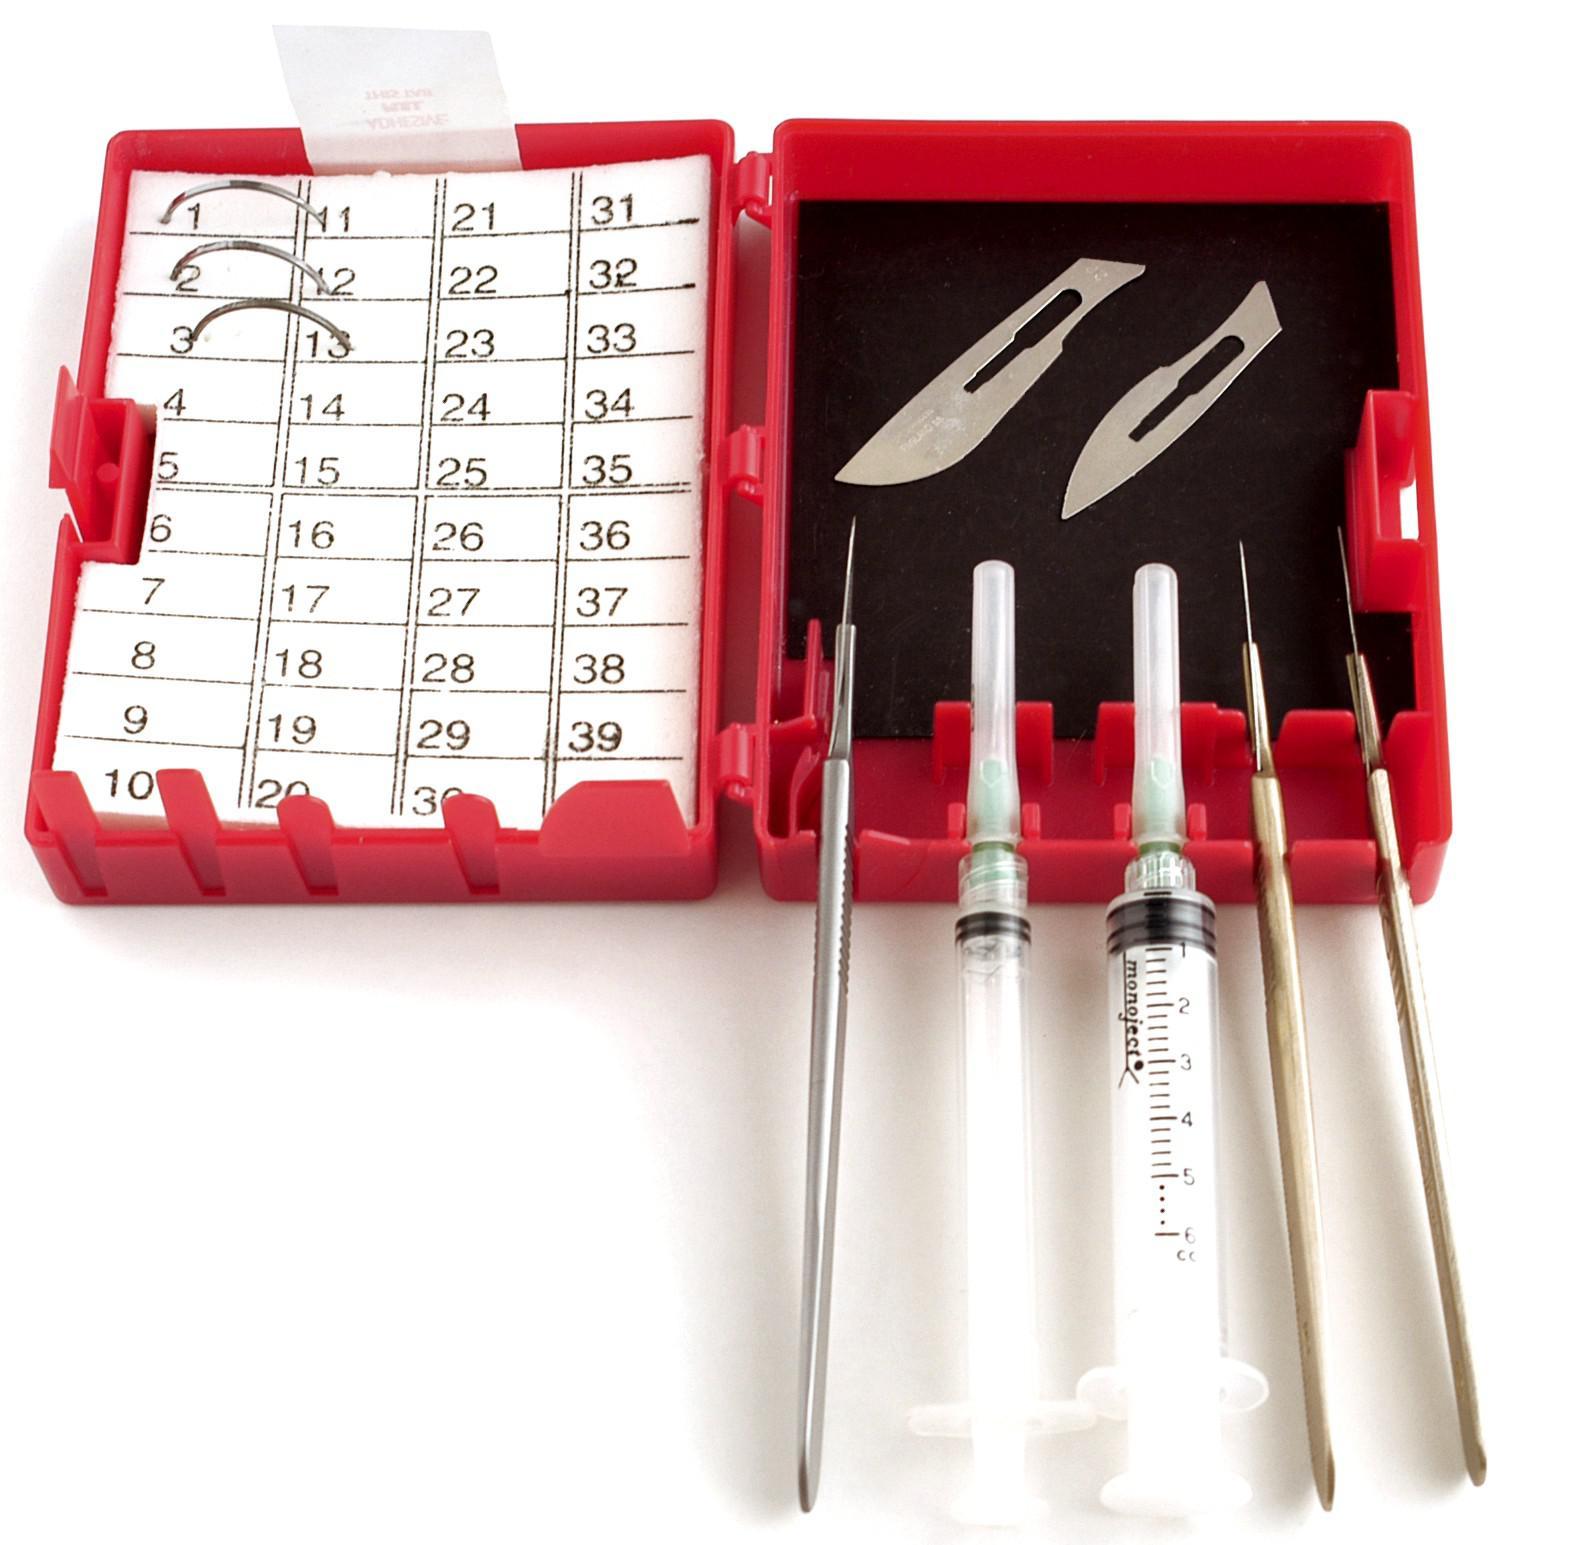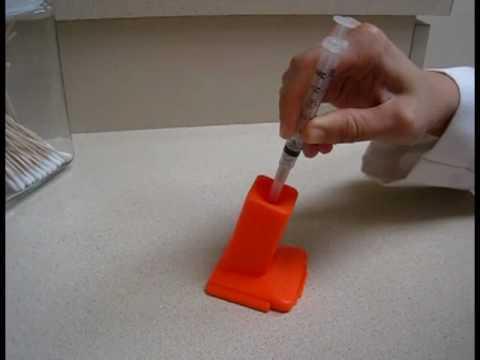The first image is the image on the left, the second image is the image on the right. Given the left and right images, does the statement "A person is inserting a syringe into an orange holder." hold true? Answer yes or no. Yes. 